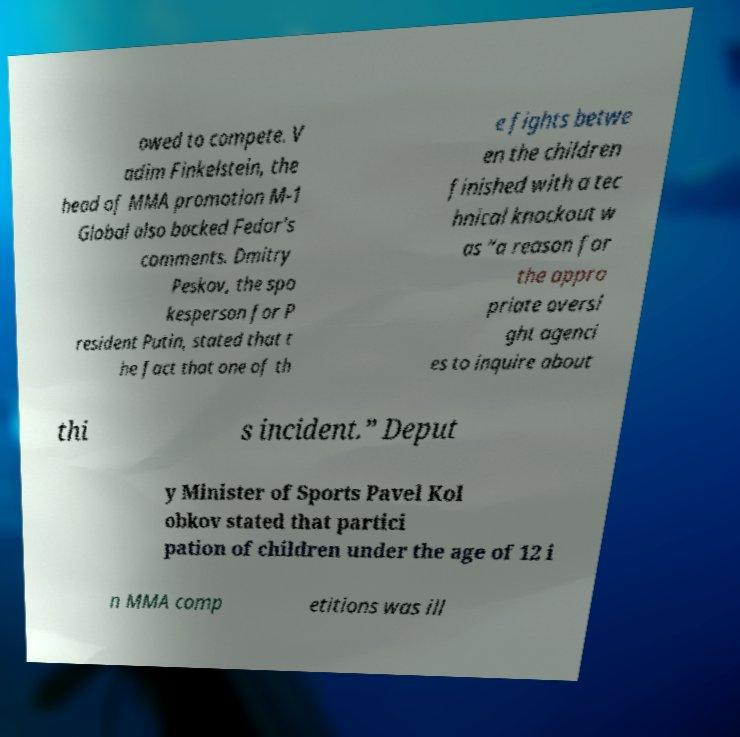Could you assist in decoding the text presented in this image and type it out clearly? owed to compete. V adim Finkelstein, the head of MMA promotion M-1 Global also backed Fedor's comments. Dmitry Peskov, the spo kesperson for P resident Putin, stated that t he fact that one of th e fights betwe en the children finished with a tec hnical knockout w as “a reason for the appro priate oversi ght agenci es to inquire about thi s incident.” Deput y Minister of Sports Pavel Kol obkov stated that partici pation of children under the age of 12 i n MMA comp etitions was ill 